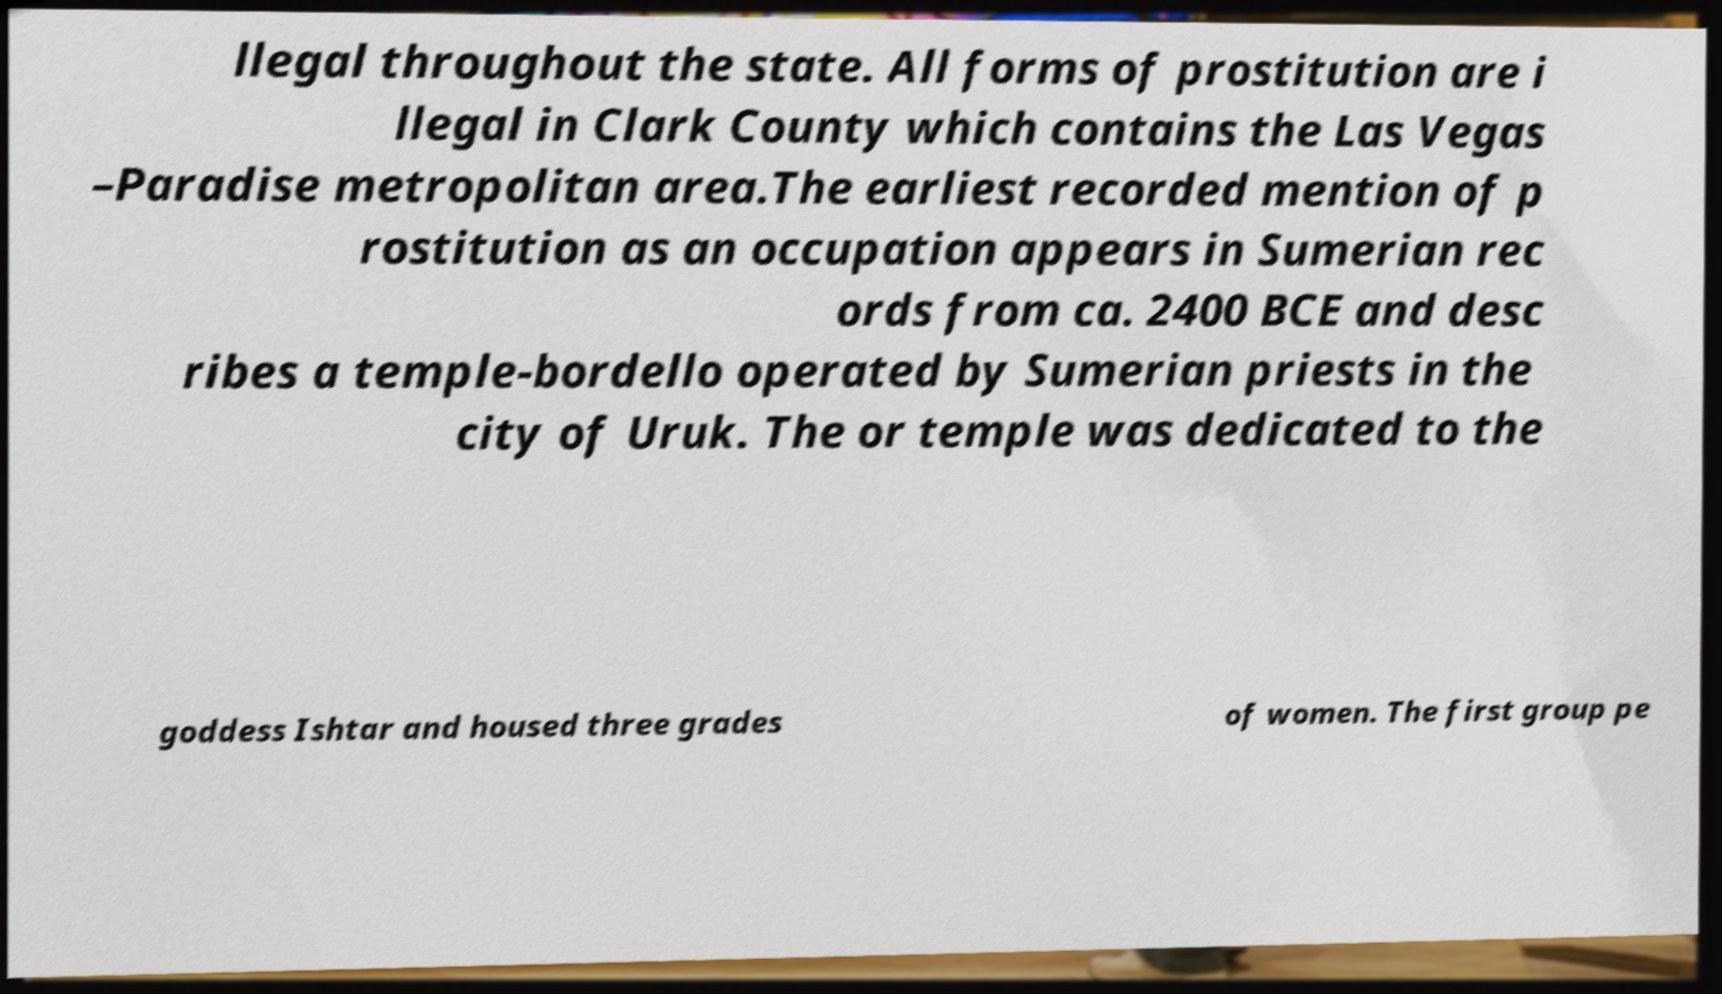There's text embedded in this image that I need extracted. Can you transcribe it verbatim? llegal throughout the state. All forms of prostitution are i llegal in Clark County which contains the Las Vegas –Paradise metropolitan area.The earliest recorded mention of p rostitution as an occupation appears in Sumerian rec ords from ca. 2400 BCE and desc ribes a temple-bordello operated by Sumerian priests in the city of Uruk. The or temple was dedicated to the goddess Ishtar and housed three grades of women. The first group pe 